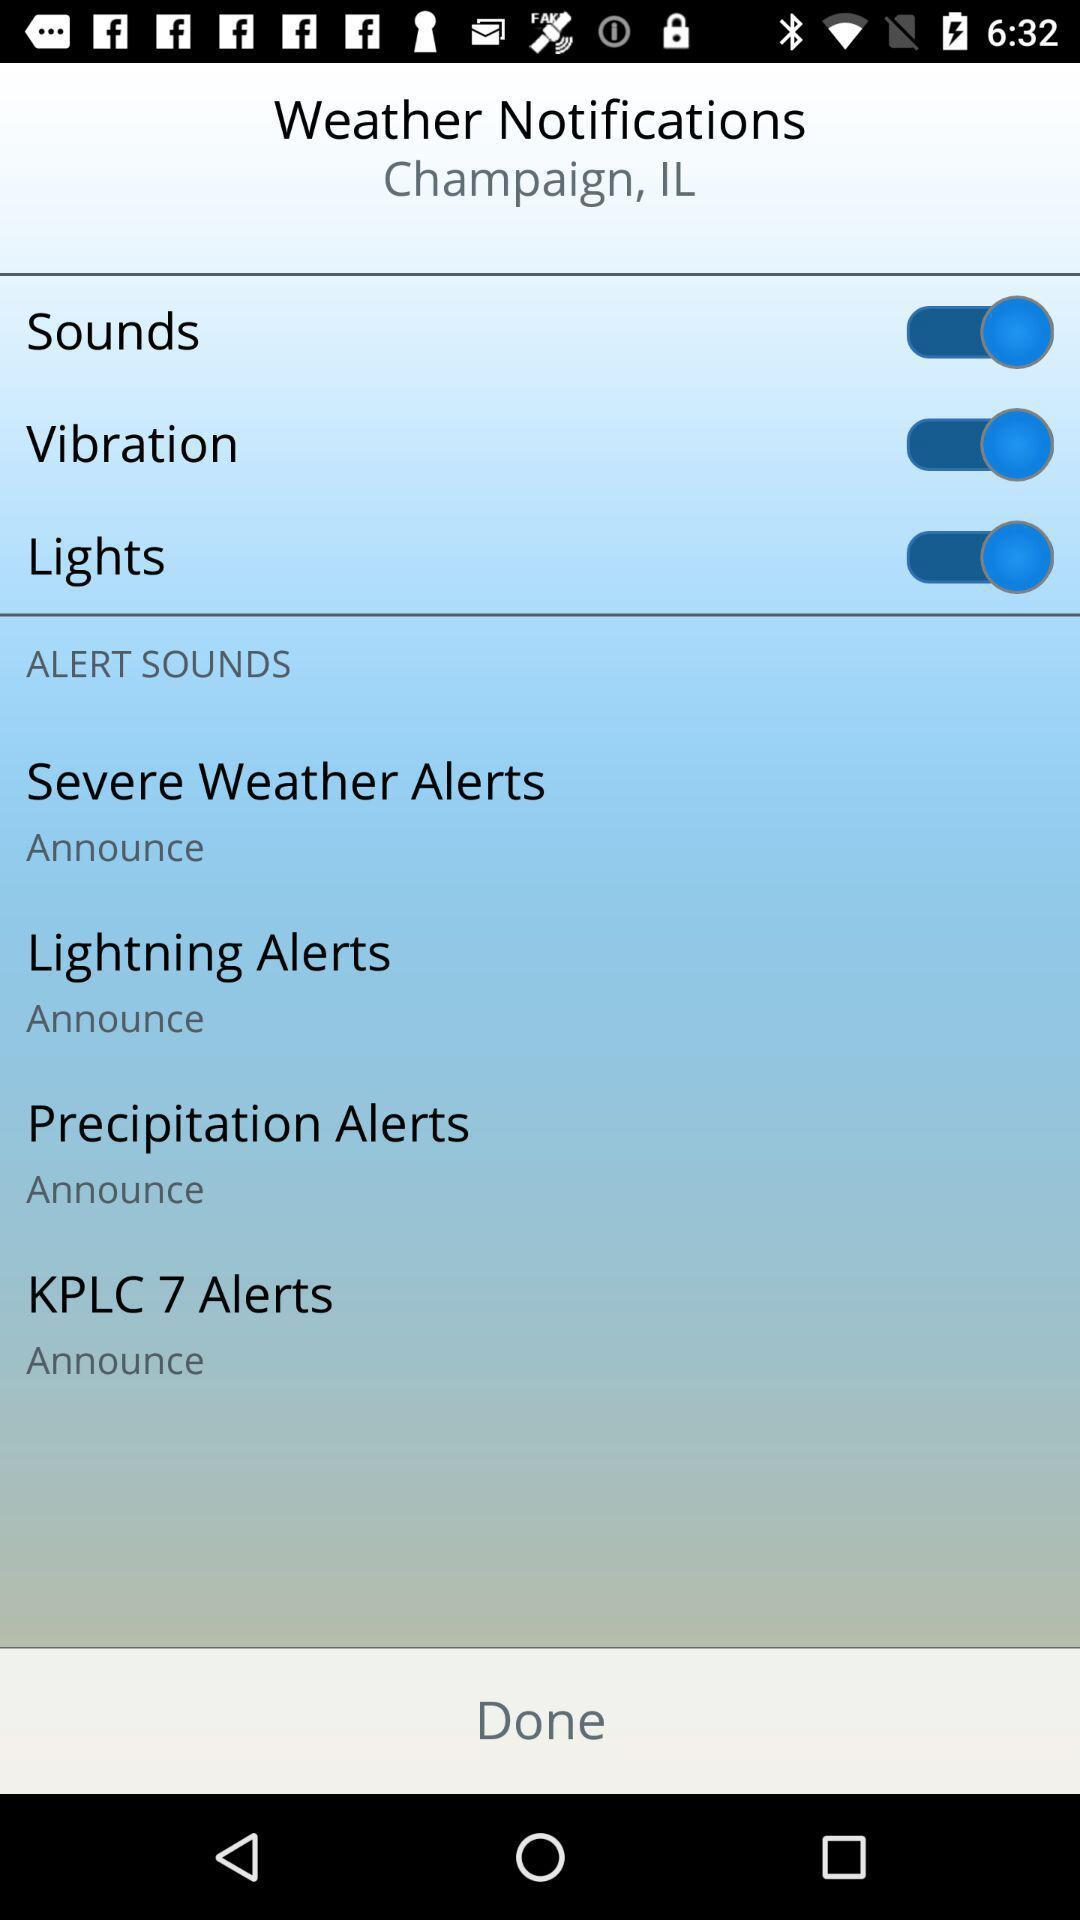What is the given location? The given location is Champaign, IL. 